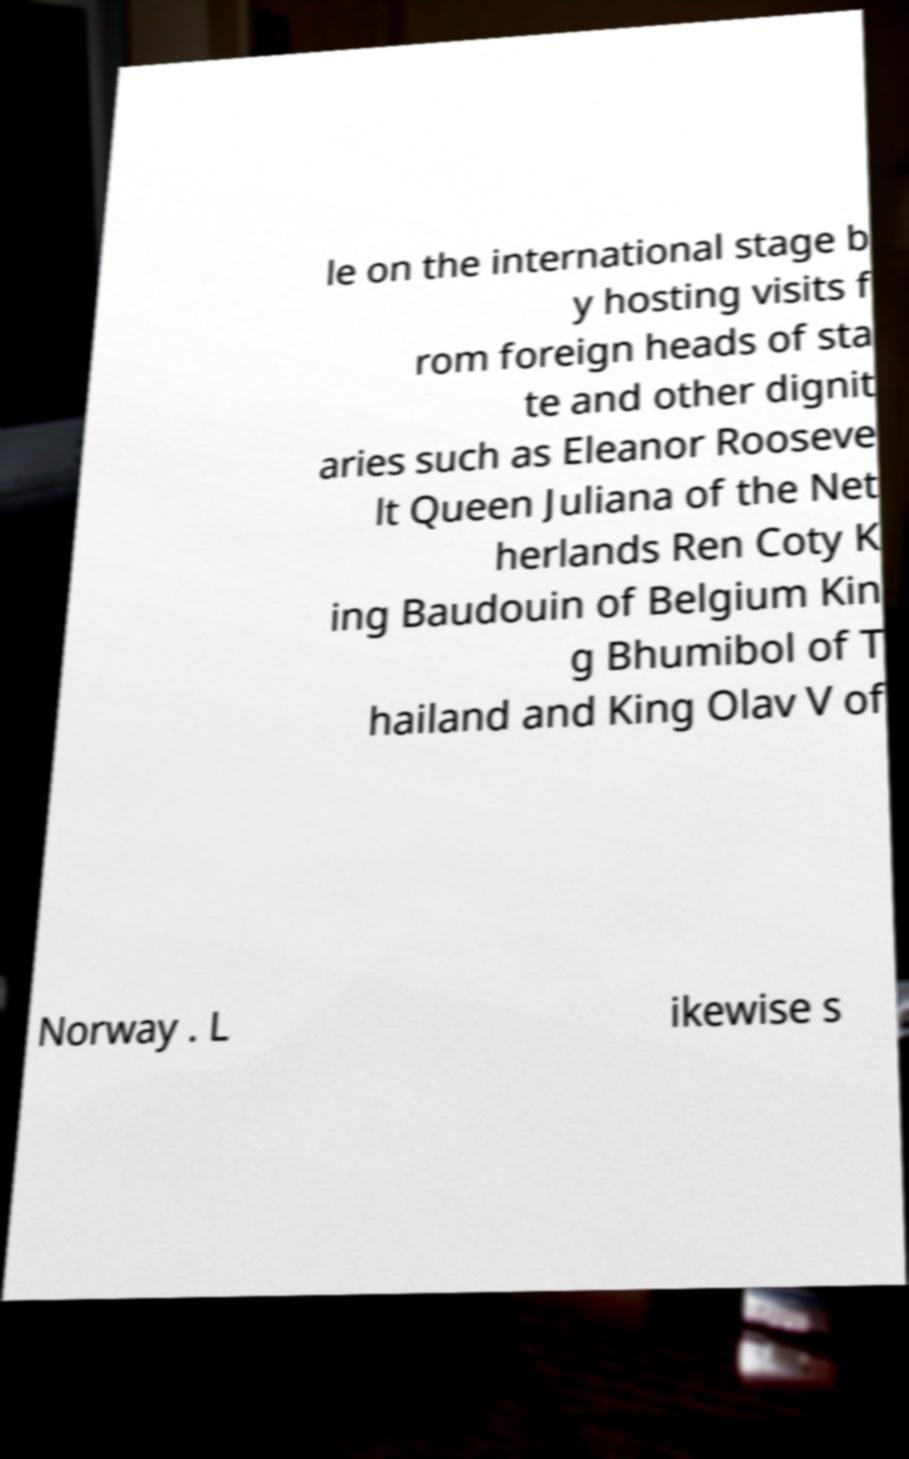I need the written content from this picture converted into text. Can you do that? le on the international stage b y hosting visits f rom foreign heads of sta te and other dignit aries such as Eleanor Rooseve lt Queen Juliana of the Net herlands Ren Coty K ing Baudouin of Belgium Kin g Bhumibol of T hailand and King Olav V of Norway . L ikewise s 